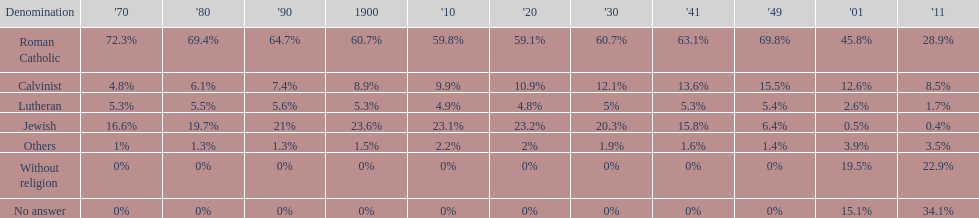Which denomination has the highest margin? Roman Catholic. 